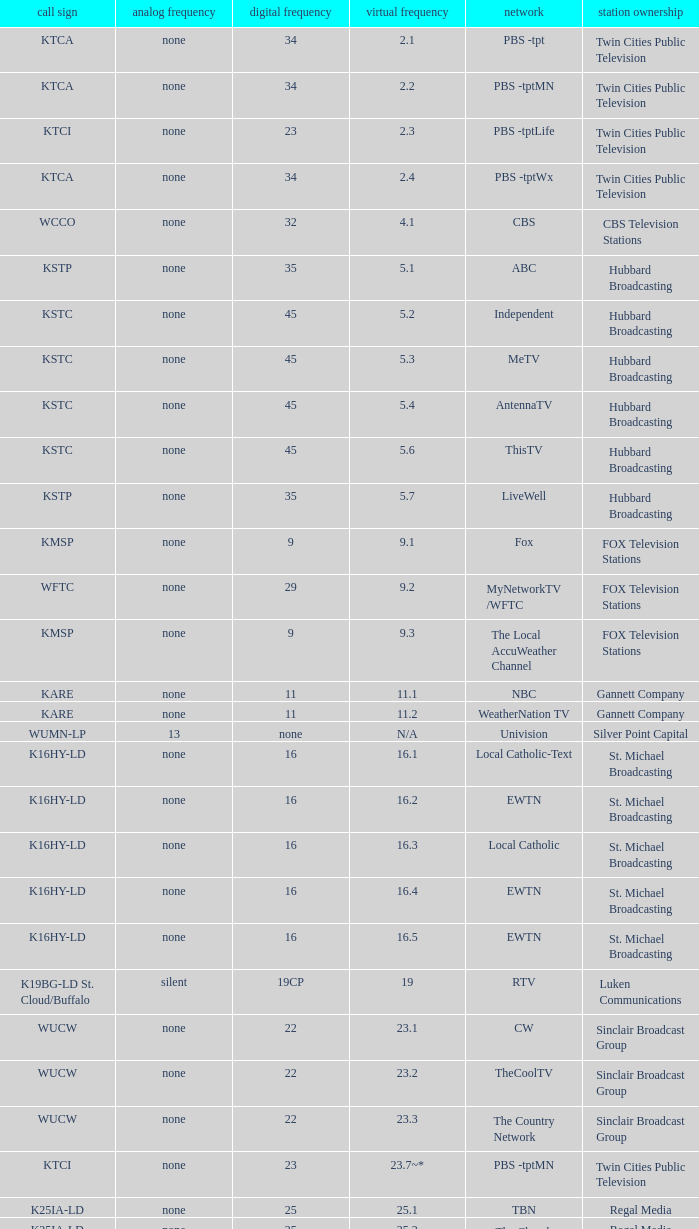Parse the full table. {'header': ['call sign', 'analog frequency', 'digital frequency', 'virtual frequency', 'network', 'station ownership'], 'rows': [['KTCA', 'none', '34', '2.1', 'PBS -tpt', 'Twin Cities Public Television'], ['KTCA', 'none', '34', '2.2', 'PBS -tptMN', 'Twin Cities Public Television'], ['KTCI', 'none', '23', '2.3', 'PBS -tptLife', 'Twin Cities Public Television'], ['KTCA', 'none', '34', '2.4', 'PBS -tptWx', 'Twin Cities Public Television'], ['WCCO', 'none', '32', '4.1', 'CBS', 'CBS Television Stations'], ['KSTP', 'none', '35', '5.1', 'ABC', 'Hubbard Broadcasting'], ['KSTC', 'none', '45', '5.2', 'Independent', 'Hubbard Broadcasting'], ['KSTC', 'none', '45', '5.3', 'MeTV', 'Hubbard Broadcasting'], ['KSTC', 'none', '45', '5.4', 'AntennaTV', 'Hubbard Broadcasting'], ['KSTC', 'none', '45', '5.6', 'ThisTV', 'Hubbard Broadcasting'], ['KSTP', 'none', '35', '5.7', 'LiveWell', 'Hubbard Broadcasting'], ['KMSP', 'none', '9', '9.1', 'Fox', 'FOX Television Stations'], ['WFTC', 'none', '29', '9.2', 'MyNetworkTV /WFTC', 'FOX Television Stations'], ['KMSP', 'none', '9', '9.3', 'The Local AccuWeather Channel', 'FOX Television Stations'], ['KARE', 'none', '11', '11.1', 'NBC', 'Gannett Company'], ['KARE', 'none', '11', '11.2', 'WeatherNation TV', 'Gannett Company'], ['WUMN-LP', '13', 'none', 'N/A', 'Univision', 'Silver Point Capital'], ['K16HY-LD', 'none', '16', '16.1', 'Local Catholic-Text', 'St. Michael Broadcasting'], ['K16HY-LD', 'none', '16', '16.2', 'EWTN', 'St. Michael Broadcasting'], ['K16HY-LD', 'none', '16', '16.3', 'Local Catholic', 'St. Michael Broadcasting'], ['K16HY-LD', 'none', '16', '16.4', 'EWTN', 'St. Michael Broadcasting'], ['K16HY-LD', 'none', '16', '16.5', 'EWTN', 'St. Michael Broadcasting'], ['K19BG-LD St. Cloud/Buffalo', 'silent', '19CP', '19', 'RTV', 'Luken Communications'], ['WUCW', 'none', '22', '23.1', 'CW', 'Sinclair Broadcast Group'], ['WUCW', 'none', '22', '23.2', 'TheCoolTV', 'Sinclair Broadcast Group'], ['WUCW', 'none', '22', '23.3', 'The Country Network', 'Sinclair Broadcast Group'], ['KTCI', 'none', '23', '23.7~*', 'PBS -tptMN', 'Twin Cities Public Television'], ['K25IA-LD', 'none', '25', '25.1', 'TBN', 'Regal Media'], ['K25IA-LD', 'none', '25', '25.2', 'The Church Channel', 'Regal Media'], ['K25IA-LD', 'none', '25', '25.3', 'JCTV', 'Regal Media'], ['K25IA-LD', 'none', '25', '25.4', 'Smile Of A Child', 'Regal Media'], ['K25IA-LD', 'none', '25', '25.5', 'TBN Enlace', 'Regal Media'], ['W47CO-LD River Falls, Wisc.', 'none', '47', '28.1', 'PBS /WHWC', 'Wisconsin Public Television'], ['W47CO-LD River Falls, Wisc.', 'none', '47', '28.2', 'PBS -WISC/WHWC', 'Wisconsin Public Television'], ['W47CO-LD River Falls, Wisc.', 'none', '47', '28.3', 'PBS -Create/WHWC', 'Wisconsin Public Television'], ['WFTC', 'none', '29', '29.1', 'MyNetworkTV', 'FOX Television Stations'], ['KMSP', 'none', '9', '29.2', 'MyNetworkTV /WFTC', 'FOX Television Stations'], ['WFTC', 'none', '29', '29.3', 'Bounce TV', 'FOX Television Stations'], ['WFTC', 'none', '29', '29.4', 'Movies!', 'FOX Television Stations'], ['K33LN-LD', 'none', '33', '33.1', '3ABN', 'Three Angels Broadcasting Network'], ['K33LN-LD', 'none', '33', '33.2', '3ABN Proclaim!', 'Three Angels Broadcasting Network'], ['K33LN-LD', 'none', '33', '33.3', '3ABN Dare to Dream', 'Three Angels Broadcasting Network'], ['K33LN-LD', 'none', '33', '33.4', '3ABN Latino', 'Three Angels Broadcasting Network'], ['K33LN-LD', 'none', '33', '33.5', '3ABN Radio-Audio', 'Three Angels Broadcasting Network'], ['K33LN-LD', 'none', '33', '33.6', '3ABN Radio Latino-Audio', 'Three Angels Broadcasting Network'], ['K33LN-LD', 'none', '33', '33.7', 'Radio 74-Audio', 'Three Angels Broadcasting Network'], ['KPXM-TV', 'none', '40', '41.1', 'Ion Television', 'Ion Media Networks'], ['KPXM-TV', 'none', '40', '41.2', 'Qubo Kids', 'Ion Media Networks'], ['KPXM-TV', 'none', '40', '41.3', 'Ion Life', 'Ion Media Networks'], ['K43HB-LD', 'none', '43', '43.1', 'HSN', 'Ventana Television'], ['KHVM-LD', 'none', '48', '48.1', 'GCN - Religious', 'EICB TV'], ['KTCJ-LD', 'none', '50', '50.1', 'CTVN - Religious', 'EICB TV'], ['WDMI-LD', 'none', '31', '62.1', 'Daystar', 'Word of God Fellowship']]} Network of nbc is what digital channel? 11.0. 